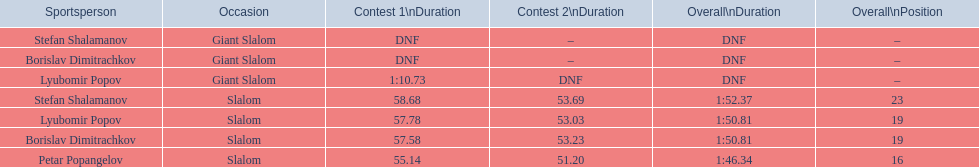What are all the competitions lyubomir popov competed in? Lyubomir Popov, Lyubomir Popov. Of those, which were giant slalom races? Giant Slalom. What was his time in race 1? 1:10.73. 